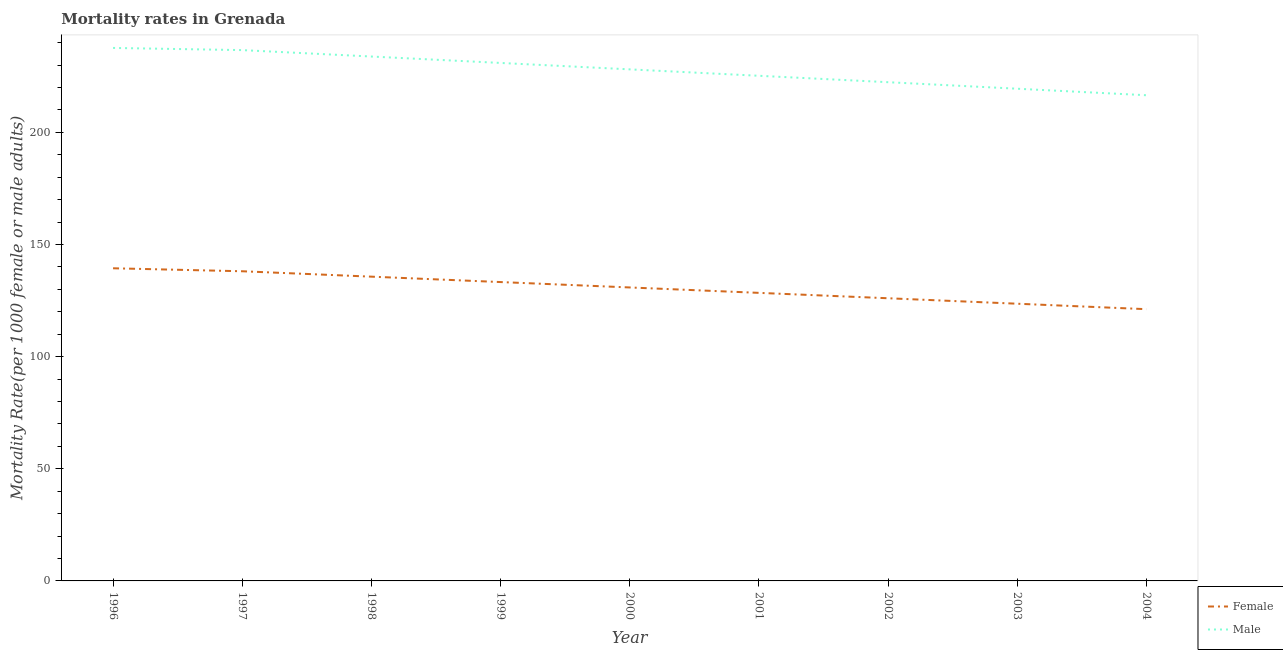Is the number of lines equal to the number of legend labels?
Your response must be concise. Yes. What is the female mortality rate in 2000?
Provide a short and direct response. 130.86. Across all years, what is the maximum female mortality rate?
Give a very brief answer. 139.41. Across all years, what is the minimum female mortality rate?
Your answer should be compact. 121.18. What is the total female mortality rate in the graph?
Your answer should be very brief. 1176.59. What is the difference between the female mortality rate in 2000 and that in 2001?
Offer a terse response. 2.41. What is the difference between the female mortality rate in 1999 and the male mortality rate in 2000?
Provide a short and direct response. -94.84. What is the average female mortality rate per year?
Keep it short and to the point. 130.73. In the year 1998, what is the difference between the female mortality rate and male mortality rate?
Provide a short and direct response. -98.16. In how many years, is the female mortality rate greater than 10?
Keep it short and to the point. 9. What is the ratio of the male mortality rate in 1999 to that in 2002?
Provide a short and direct response. 1.04. What is the difference between the highest and the second highest female mortality rate?
Your response must be concise. 1.33. What is the difference between the highest and the lowest female mortality rate?
Offer a terse response. 18.24. Is the female mortality rate strictly greater than the male mortality rate over the years?
Your response must be concise. No. How many lines are there?
Make the answer very short. 2. How many years are there in the graph?
Your response must be concise. 9. Are the values on the major ticks of Y-axis written in scientific E-notation?
Offer a very short reply. No. Does the graph contain any zero values?
Your answer should be very brief. No. Does the graph contain grids?
Give a very brief answer. No. How many legend labels are there?
Offer a very short reply. 2. What is the title of the graph?
Your response must be concise. Mortality rates in Grenada. Does "Overweight" appear as one of the legend labels in the graph?
Offer a terse response. No. What is the label or title of the Y-axis?
Offer a terse response. Mortality Rate(per 1000 female or male adults). What is the Mortality Rate(per 1000 female or male adults) of Female in 1996?
Your answer should be very brief. 139.41. What is the Mortality Rate(per 1000 female or male adults) in Male in 1996?
Keep it short and to the point. 237.67. What is the Mortality Rate(per 1000 female or male adults) in Female in 1997?
Your answer should be very brief. 138.08. What is the Mortality Rate(per 1000 female or male adults) of Male in 1997?
Provide a short and direct response. 236.7. What is the Mortality Rate(per 1000 female or male adults) of Female in 1998?
Your answer should be very brief. 135.68. What is the Mortality Rate(per 1000 female or male adults) in Male in 1998?
Your answer should be very brief. 233.84. What is the Mortality Rate(per 1000 female or male adults) of Female in 1999?
Your answer should be compact. 133.27. What is the Mortality Rate(per 1000 female or male adults) in Male in 1999?
Give a very brief answer. 230.97. What is the Mortality Rate(per 1000 female or male adults) in Female in 2000?
Keep it short and to the point. 130.86. What is the Mortality Rate(per 1000 female or male adults) in Male in 2000?
Ensure brevity in your answer.  228.11. What is the Mortality Rate(per 1000 female or male adults) in Female in 2001?
Give a very brief answer. 128.45. What is the Mortality Rate(per 1000 female or male adults) of Male in 2001?
Keep it short and to the point. 225.25. What is the Mortality Rate(per 1000 female or male adults) of Female in 2002?
Provide a succinct answer. 126.05. What is the Mortality Rate(per 1000 female or male adults) in Male in 2002?
Ensure brevity in your answer.  222.39. What is the Mortality Rate(per 1000 female or male adults) of Female in 2003?
Provide a short and direct response. 123.61. What is the Mortality Rate(per 1000 female or male adults) in Male in 2003?
Your response must be concise. 219.48. What is the Mortality Rate(per 1000 female or male adults) in Female in 2004?
Your response must be concise. 121.18. What is the Mortality Rate(per 1000 female or male adults) in Male in 2004?
Offer a terse response. 216.58. Across all years, what is the maximum Mortality Rate(per 1000 female or male adults) of Female?
Offer a terse response. 139.41. Across all years, what is the maximum Mortality Rate(per 1000 female or male adults) of Male?
Provide a succinct answer. 237.67. Across all years, what is the minimum Mortality Rate(per 1000 female or male adults) of Female?
Offer a very short reply. 121.18. Across all years, what is the minimum Mortality Rate(per 1000 female or male adults) in Male?
Offer a terse response. 216.58. What is the total Mortality Rate(per 1000 female or male adults) in Female in the graph?
Provide a succinct answer. 1176.59. What is the total Mortality Rate(per 1000 female or male adults) in Male in the graph?
Offer a very short reply. 2050.99. What is the difference between the Mortality Rate(per 1000 female or male adults) of Female in 1996 and that in 1997?
Your answer should be compact. 1.33. What is the difference between the Mortality Rate(per 1000 female or male adults) in Female in 1996 and that in 1998?
Provide a short and direct response. 3.74. What is the difference between the Mortality Rate(per 1000 female or male adults) of Male in 1996 and that in 1998?
Provide a succinct answer. 3.83. What is the difference between the Mortality Rate(per 1000 female or male adults) in Female in 1996 and that in 1999?
Offer a very short reply. 6.14. What is the difference between the Mortality Rate(per 1000 female or male adults) of Male in 1996 and that in 1999?
Offer a terse response. 6.69. What is the difference between the Mortality Rate(per 1000 female or male adults) of Female in 1996 and that in 2000?
Provide a succinct answer. 8.55. What is the difference between the Mortality Rate(per 1000 female or male adults) in Male in 1996 and that in 2000?
Provide a short and direct response. 9.55. What is the difference between the Mortality Rate(per 1000 female or male adults) of Female in 1996 and that in 2001?
Keep it short and to the point. 10.96. What is the difference between the Mortality Rate(per 1000 female or male adults) in Male in 1996 and that in 2001?
Provide a succinct answer. 12.42. What is the difference between the Mortality Rate(per 1000 female or male adults) of Female in 1996 and that in 2002?
Your response must be concise. 13.37. What is the difference between the Mortality Rate(per 1000 female or male adults) in Male in 1996 and that in 2002?
Ensure brevity in your answer.  15.28. What is the difference between the Mortality Rate(per 1000 female or male adults) in Female in 1996 and that in 2003?
Make the answer very short. 15.8. What is the difference between the Mortality Rate(per 1000 female or male adults) of Male in 1996 and that in 2003?
Keep it short and to the point. 18.18. What is the difference between the Mortality Rate(per 1000 female or male adults) in Female in 1996 and that in 2004?
Offer a very short reply. 18.24. What is the difference between the Mortality Rate(per 1000 female or male adults) in Male in 1996 and that in 2004?
Give a very brief answer. 21.09. What is the difference between the Mortality Rate(per 1000 female or male adults) in Female in 1997 and that in 1998?
Keep it short and to the point. 2.41. What is the difference between the Mortality Rate(per 1000 female or male adults) in Male in 1997 and that in 1998?
Make the answer very short. 2.86. What is the difference between the Mortality Rate(per 1000 female or male adults) of Female in 1997 and that in 1999?
Your response must be concise. 4.82. What is the difference between the Mortality Rate(per 1000 female or male adults) in Male in 1997 and that in 1999?
Provide a succinct answer. 5.72. What is the difference between the Mortality Rate(per 1000 female or male adults) in Female in 1997 and that in 2000?
Your answer should be very brief. 7.22. What is the difference between the Mortality Rate(per 1000 female or male adults) in Male in 1997 and that in 2000?
Provide a succinct answer. 8.59. What is the difference between the Mortality Rate(per 1000 female or male adults) in Female in 1997 and that in 2001?
Keep it short and to the point. 9.63. What is the difference between the Mortality Rate(per 1000 female or male adults) in Male in 1997 and that in 2001?
Provide a short and direct response. 11.45. What is the difference between the Mortality Rate(per 1000 female or male adults) in Female in 1997 and that in 2002?
Give a very brief answer. 12.04. What is the difference between the Mortality Rate(per 1000 female or male adults) in Male in 1997 and that in 2002?
Your answer should be compact. 14.31. What is the difference between the Mortality Rate(per 1000 female or male adults) of Female in 1997 and that in 2003?
Make the answer very short. 14.47. What is the difference between the Mortality Rate(per 1000 female or male adults) in Male in 1997 and that in 2003?
Your answer should be very brief. 17.21. What is the difference between the Mortality Rate(per 1000 female or male adults) in Female in 1997 and that in 2004?
Make the answer very short. 16.91. What is the difference between the Mortality Rate(per 1000 female or male adults) of Male in 1997 and that in 2004?
Keep it short and to the point. 20.12. What is the difference between the Mortality Rate(per 1000 female or male adults) of Female in 1998 and that in 1999?
Keep it short and to the point. 2.41. What is the difference between the Mortality Rate(per 1000 female or male adults) in Male in 1998 and that in 1999?
Provide a short and direct response. 2.86. What is the difference between the Mortality Rate(per 1000 female or male adults) of Female in 1998 and that in 2000?
Give a very brief answer. 4.82. What is the difference between the Mortality Rate(per 1000 female or male adults) in Male in 1998 and that in 2000?
Your answer should be compact. 5.72. What is the difference between the Mortality Rate(per 1000 female or male adults) of Female in 1998 and that in 2001?
Your response must be concise. 7.22. What is the difference between the Mortality Rate(per 1000 female or male adults) of Male in 1998 and that in 2001?
Make the answer very short. 8.59. What is the difference between the Mortality Rate(per 1000 female or male adults) of Female in 1998 and that in 2002?
Give a very brief answer. 9.63. What is the difference between the Mortality Rate(per 1000 female or male adults) of Male in 1998 and that in 2002?
Ensure brevity in your answer.  11.45. What is the difference between the Mortality Rate(per 1000 female or male adults) of Female in 1998 and that in 2003?
Your answer should be very brief. 12.06. What is the difference between the Mortality Rate(per 1000 female or male adults) in Male in 1998 and that in 2003?
Your response must be concise. 14.35. What is the difference between the Mortality Rate(per 1000 female or male adults) of Male in 1998 and that in 2004?
Offer a terse response. 17.26. What is the difference between the Mortality Rate(per 1000 female or male adults) in Female in 1999 and that in 2000?
Make the answer very short. 2.41. What is the difference between the Mortality Rate(per 1000 female or male adults) of Male in 1999 and that in 2000?
Offer a very short reply. 2.86. What is the difference between the Mortality Rate(per 1000 female or male adults) of Female in 1999 and that in 2001?
Keep it short and to the point. 4.82. What is the difference between the Mortality Rate(per 1000 female or male adults) in Male in 1999 and that in 2001?
Provide a short and direct response. 5.72. What is the difference between the Mortality Rate(per 1000 female or male adults) of Female in 1999 and that in 2002?
Ensure brevity in your answer.  7.22. What is the difference between the Mortality Rate(per 1000 female or male adults) in Male in 1999 and that in 2002?
Offer a very short reply. 8.59. What is the difference between the Mortality Rate(per 1000 female or male adults) in Female in 1999 and that in 2003?
Your answer should be very brief. 9.66. What is the difference between the Mortality Rate(per 1000 female or male adults) in Male in 1999 and that in 2003?
Your answer should be very brief. 11.49. What is the difference between the Mortality Rate(per 1000 female or male adults) of Female in 1999 and that in 2004?
Your answer should be very brief. 12.09. What is the difference between the Mortality Rate(per 1000 female or male adults) of Male in 1999 and that in 2004?
Offer a very short reply. 14.4. What is the difference between the Mortality Rate(per 1000 female or male adults) in Female in 2000 and that in 2001?
Offer a terse response. 2.41. What is the difference between the Mortality Rate(per 1000 female or male adults) in Male in 2000 and that in 2001?
Give a very brief answer. 2.86. What is the difference between the Mortality Rate(per 1000 female or male adults) of Female in 2000 and that in 2002?
Make the answer very short. 4.82. What is the difference between the Mortality Rate(per 1000 female or male adults) in Male in 2000 and that in 2002?
Ensure brevity in your answer.  5.72. What is the difference between the Mortality Rate(per 1000 female or male adults) in Female in 2000 and that in 2003?
Your response must be concise. 7.25. What is the difference between the Mortality Rate(per 1000 female or male adults) of Male in 2000 and that in 2003?
Make the answer very short. 8.63. What is the difference between the Mortality Rate(per 1000 female or male adults) of Female in 2000 and that in 2004?
Your answer should be compact. 9.69. What is the difference between the Mortality Rate(per 1000 female or male adults) of Male in 2000 and that in 2004?
Make the answer very short. 11.53. What is the difference between the Mortality Rate(per 1000 female or male adults) in Female in 2001 and that in 2002?
Your answer should be very brief. 2.41. What is the difference between the Mortality Rate(per 1000 female or male adults) of Male in 2001 and that in 2002?
Provide a short and direct response. 2.86. What is the difference between the Mortality Rate(per 1000 female or male adults) in Female in 2001 and that in 2003?
Your response must be concise. 4.84. What is the difference between the Mortality Rate(per 1000 female or male adults) in Male in 2001 and that in 2003?
Provide a short and direct response. 5.77. What is the difference between the Mortality Rate(per 1000 female or male adults) of Female in 2001 and that in 2004?
Your response must be concise. 7.28. What is the difference between the Mortality Rate(per 1000 female or male adults) in Male in 2001 and that in 2004?
Offer a very short reply. 8.67. What is the difference between the Mortality Rate(per 1000 female or male adults) of Female in 2002 and that in 2003?
Your response must be concise. 2.43. What is the difference between the Mortality Rate(per 1000 female or male adults) in Male in 2002 and that in 2003?
Keep it short and to the point. 2.9. What is the difference between the Mortality Rate(per 1000 female or male adults) in Female in 2002 and that in 2004?
Keep it short and to the point. 4.87. What is the difference between the Mortality Rate(per 1000 female or male adults) of Male in 2002 and that in 2004?
Provide a succinct answer. 5.81. What is the difference between the Mortality Rate(per 1000 female or male adults) of Female in 2003 and that in 2004?
Ensure brevity in your answer.  2.44. What is the difference between the Mortality Rate(per 1000 female or male adults) of Male in 2003 and that in 2004?
Make the answer very short. 2.9. What is the difference between the Mortality Rate(per 1000 female or male adults) in Female in 1996 and the Mortality Rate(per 1000 female or male adults) in Male in 1997?
Provide a succinct answer. -97.29. What is the difference between the Mortality Rate(per 1000 female or male adults) of Female in 1996 and the Mortality Rate(per 1000 female or male adults) of Male in 1998?
Your response must be concise. -94.42. What is the difference between the Mortality Rate(per 1000 female or male adults) in Female in 1996 and the Mortality Rate(per 1000 female or male adults) in Male in 1999?
Keep it short and to the point. -91.56. What is the difference between the Mortality Rate(per 1000 female or male adults) of Female in 1996 and the Mortality Rate(per 1000 female or male adults) of Male in 2000?
Make the answer very short. -88.7. What is the difference between the Mortality Rate(per 1000 female or male adults) in Female in 1996 and the Mortality Rate(per 1000 female or male adults) in Male in 2001?
Offer a very short reply. -85.84. What is the difference between the Mortality Rate(per 1000 female or male adults) in Female in 1996 and the Mortality Rate(per 1000 female or male adults) in Male in 2002?
Your answer should be compact. -82.98. What is the difference between the Mortality Rate(per 1000 female or male adults) in Female in 1996 and the Mortality Rate(per 1000 female or male adults) in Male in 2003?
Your answer should be compact. -80.07. What is the difference between the Mortality Rate(per 1000 female or male adults) of Female in 1996 and the Mortality Rate(per 1000 female or male adults) of Male in 2004?
Provide a short and direct response. -77.17. What is the difference between the Mortality Rate(per 1000 female or male adults) of Female in 1997 and the Mortality Rate(per 1000 female or male adults) of Male in 1998?
Keep it short and to the point. -95.75. What is the difference between the Mortality Rate(per 1000 female or male adults) in Female in 1997 and the Mortality Rate(per 1000 female or male adults) in Male in 1999?
Provide a short and direct response. -92.89. What is the difference between the Mortality Rate(per 1000 female or male adults) in Female in 1997 and the Mortality Rate(per 1000 female or male adults) in Male in 2000?
Give a very brief answer. -90.03. What is the difference between the Mortality Rate(per 1000 female or male adults) of Female in 1997 and the Mortality Rate(per 1000 female or male adults) of Male in 2001?
Your answer should be compact. -87.17. What is the difference between the Mortality Rate(per 1000 female or male adults) in Female in 1997 and the Mortality Rate(per 1000 female or male adults) in Male in 2002?
Ensure brevity in your answer.  -84.3. What is the difference between the Mortality Rate(per 1000 female or male adults) of Female in 1997 and the Mortality Rate(per 1000 female or male adults) of Male in 2003?
Ensure brevity in your answer.  -81.4. What is the difference between the Mortality Rate(per 1000 female or male adults) of Female in 1997 and the Mortality Rate(per 1000 female or male adults) of Male in 2004?
Offer a terse response. -78.49. What is the difference between the Mortality Rate(per 1000 female or male adults) in Female in 1998 and the Mortality Rate(per 1000 female or male adults) in Male in 1999?
Offer a terse response. -95.3. What is the difference between the Mortality Rate(per 1000 female or male adults) in Female in 1998 and the Mortality Rate(per 1000 female or male adults) in Male in 2000?
Your response must be concise. -92.44. What is the difference between the Mortality Rate(per 1000 female or male adults) of Female in 1998 and the Mortality Rate(per 1000 female or male adults) of Male in 2001?
Ensure brevity in your answer.  -89.57. What is the difference between the Mortality Rate(per 1000 female or male adults) in Female in 1998 and the Mortality Rate(per 1000 female or male adults) in Male in 2002?
Provide a short and direct response. -86.71. What is the difference between the Mortality Rate(per 1000 female or male adults) in Female in 1998 and the Mortality Rate(per 1000 female or male adults) in Male in 2003?
Provide a succinct answer. -83.81. What is the difference between the Mortality Rate(per 1000 female or male adults) of Female in 1998 and the Mortality Rate(per 1000 female or male adults) of Male in 2004?
Your answer should be very brief. -80.9. What is the difference between the Mortality Rate(per 1000 female or male adults) of Female in 1999 and the Mortality Rate(per 1000 female or male adults) of Male in 2000?
Ensure brevity in your answer.  -94.84. What is the difference between the Mortality Rate(per 1000 female or male adults) of Female in 1999 and the Mortality Rate(per 1000 female or male adults) of Male in 2001?
Offer a terse response. -91.98. What is the difference between the Mortality Rate(per 1000 female or male adults) in Female in 1999 and the Mortality Rate(per 1000 female or male adults) in Male in 2002?
Provide a succinct answer. -89.12. What is the difference between the Mortality Rate(per 1000 female or male adults) of Female in 1999 and the Mortality Rate(per 1000 female or male adults) of Male in 2003?
Offer a very short reply. -86.21. What is the difference between the Mortality Rate(per 1000 female or male adults) of Female in 1999 and the Mortality Rate(per 1000 female or male adults) of Male in 2004?
Make the answer very short. -83.31. What is the difference between the Mortality Rate(per 1000 female or male adults) of Female in 2000 and the Mortality Rate(per 1000 female or male adults) of Male in 2001?
Provide a succinct answer. -94.39. What is the difference between the Mortality Rate(per 1000 female or male adults) of Female in 2000 and the Mortality Rate(per 1000 female or male adults) of Male in 2002?
Provide a succinct answer. -91.53. What is the difference between the Mortality Rate(per 1000 female or male adults) in Female in 2000 and the Mortality Rate(per 1000 female or male adults) in Male in 2003?
Offer a very short reply. -88.62. What is the difference between the Mortality Rate(per 1000 female or male adults) of Female in 2000 and the Mortality Rate(per 1000 female or male adults) of Male in 2004?
Provide a short and direct response. -85.72. What is the difference between the Mortality Rate(per 1000 female or male adults) in Female in 2001 and the Mortality Rate(per 1000 female or male adults) in Male in 2002?
Your answer should be very brief. -93.94. What is the difference between the Mortality Rate(per 1000 female or male adults) in Female in 2001 and the Mortality Rate(per 1000 female or male adults) in Male in 2003?
Give a very brief answer. -91.03. What is the difference between the Mortality Rate(per 1000 female or male adults) of Female in 2001 and the Mortality Rate(per 1000 female or male adults) of Male in 2004?
Give a very brief answer. -88.12. What is the difference between the Mortality Rate(per 1000 female or male adults) in Female in 2002 and the Mortality Rate(per 1000 female or male adults) in Male in 2003?
Offer a very short reply. -93.44. What is the difference between the Mortality Rate(per 1000 female or male adults) of Female in 2002 and the Mortality Rate(per 1000 female or male adults) of Male in 2004?
Keep it short and to the point. -90.53. What is the difference between the Mortality Rate(per 1000 female or male adults) in Female in 2003 and the Mortality Rate(per 1000 female or male adults) in Male in 2004?
Your response must be concise. -92.97. What is the average Mortality Rate(per 1000 female or male adults) in Female per year?
Offer a terse response. 130.73. What is the average Mortality Rate(per 1000 female or male adults) in Male per year?
Give a very brief answer. 227.89. In the year 1996, what is the difference between the Mortality Rate(per 1000 female or male adults) in Female and Mortality Rate(per 1000 female or male adults) in Male?
Ensure brevity in your answer.  -98.25. In the year 1997, what is the difference between the Mortality Rate(per 1000 female or male adults) in Female and Mortality Rate(per 1000 female or male adults) in Male?
Provide a succinct answer. -98.61. In the year 1998, what is the difference between the Mortality Rate(per 1000 female or male adults) of Female and Mortality Rate(per 1000 female or male adults) of Male?
Offer a very short reply. -98.16. In the year 1999, what is the difference between the Mortality Rate(per 1000 female or male adults) in Female and Mortality Rate(per 1000 female or male adults) in Male?
Offer a very short reply. -97.7. In the year 2000, what is the difference between the Mortality Rate(per 1000 female or male adults) in Female and Mortality Rate(per 1000 female or male adults) in Male?
Offer a terse response. -97.25. In the year 2001, what is the difference between the Mortality Rate(per 1000 female or male adults) of Female and Mortality Rate(per 1000 female or male adults) of Male?
Provide a short and direct response. -96.8. In the year 2002, what is the difference between the Mortality Rate(per 1000 female or male adults) in Female and Mortality Rate(per 1000 female or male adults) in Male?
Offer a terse response. -96.34. In the year 2003, what is the difference between the Mortality Rate(per 1000 female or male adults) in Female and Mortality Rate(per 1000 female or male adults) in Male?
Provide a succinct answer. -95.87. In the year 2004, what is the difference between the Mortality Rate(per 1000 female or male adults) of Female and Mortality Rate(per 1000 female or male adults) of Male?
Ensure brevity in your answer.  -95.4. What is the ratio of the Mortality Rate(per 1000 female or male adults) of Female in 1996 to that in 1997?
Keep it short and to the point. 1.01. What is the ratio of the Mortality Rate(per 1000 female or male adults) of Male in 1996 to that in 1997?
Offer a terse response. 1. What is the ratio of the Mortality Rate(per 1000 female or male adults) of Female in 1996 to that in 1998?
Keep it short and to the point. 1.03. What is the ratio of the Mortality Rate(per 1000 female or male adults) of Male in 1996 to that in 1998?
Give a very brief answer. 1.02. What is the ratio of the Mortality Rate(per 1000 female or male adults) in Female in 1996 to that in 1999?
Your answer should be very brief. 1.05. What is the ratio of the Mortality Rate(per 1000 female or male adults) in Male in 1996 to that in 1999?
Your response must be concise. 1.03. What is the ratio of the Mortality Rate(per 1000 female or male adults) in Female in 1996 to that in 2000?
Offer a very short reply. 1.07. What is the ratio of the Mortality Rate(per 1000 female or male adults) in Male in 1996 to that in 2000?
Ensure brevity in your answer.  1.04. What is the ratio of the Mortality Rate(per 1000 female or male adults) in Female in 1996 to that in 2001?
Your answer should be very brief. 1.09. What is the ratio of the Mortality Rate(per 1000 female or male adults) in Male in 1996 to that in 2001?
Give a very brief answer. 1.06. What is the ratio of the Mortality Rate(per 1000 female or male adults) of Female in 1996 to that in 2002?
Give a very brief answer. 1.11. What is the ratio of the Mortality Rate(per 1000 female or male adults) of Male in 1996 to that in 2002?
Your answer should be compact. 1.07. What is the ratio of the Mortality Rate(per 1000 female or male adults) of Female in 1996 to that in 2003?
Offer a very short reply. 1.13. What is the ratio of the Mortality Rate(per 1000 female or male adults) in Male in 1996 to that in 2003?
Your answer should be very brief. 1.08. What is the ratio of the Mortality Rate(per 1000 female or male adults) in Female in 1996 to that in 2004?
Your response must be concise. 1.15. What is the ratio of the Mortality Rate(per 1000 female or male adults) in Male in 1996 to that in 2004?
Give a very brief answer. 1.1. What is the ratio of the Mortality Rate(per 1000 female or male adults) of Female in 1997 to that in 1998?
Ensure brevity in your answer.  1.02. What is the ratio of the Mortality Rate(per 1000 female or male adults) of Male in 1997 to that in 1998?
Give a very brief answer. 1.01. What is the ratio of the Mortality Rate(per 1000 female or male adults) in Female in 1997 to that in 1999?
Ensure brevity in your answer.  1.04. What is the ratio of the Mortality Rate(per 1000 female or male adults) in Male in 1997 to that in 1999?
Provide a short and direct response. 1.02. What is the ratio of the Mortality Rate(per 1000 female or male adults) of Female in 1997 to that in 2000?
Offer a terse response. 1.06. What is the ratio of the Mortality Rate(per 1000 female or male adults) in Male in 1997 to that in 2000?
Your answer should be very brief. 1.04. What is the ratio of the Mortality Rate(per 1000 female or male adults) in Female in 1997 to that in 2001?
Your answer should be compact. 1.07. What is the ratio of the Mortality Rate(per 1000 female or male adults) in Male in 1997 to that in 2001?
Ensure brevity in your answer.  1.05. What is the ratio of the Mortality Rate(per 1000 female or male adults) of Female in 1997 to that in 2002?
Offer a terse response. 1.1. What is the ratio of the Mortality Rate(per 1000 female or male adults) of Male in 1997 to that in 2002?
Your answer should be compact. 1.06. What is the ratio of the Mortality Rate(per 1000 female or male adults) in Female in 1997 to that in 2003?
Keep it short and to the point. 1.12. What is the ratio of the Mortality Rate(per 1000 female or male adults) in Male in 1997 to that in 2003?
Your answer should be compact. 1.08. What is the ratio of the Mortality Rate(per 1000 female or male adults) in Female in 1997 to that in 2004?
Offer a very short reply. 1.14. What is the ratio of the Mortality Rate(per 1000 female or male adults) of Male in 1997 to that in 2004?
Provide a short and direct response. 1.09. What is the ratio of the Mortality Rate(per 1000 female or male adults) of Female in 1998 to that in 1999?
Ensure brevity in your answer.  1.02. What is the ratio of the Mortality Rate(per 1000 female or male adults) of Male in 1998 to that in 1999?
Keep it short and to the point. 1.01. What is the ratio of the Mortality Rate(per 1000 female or male adults) of Female in 1998 to that in 2000?
Your answer should be very brief. 1.04. What is the ratio of the Mortality Rate(per 1000 female or male adults) of Male in 1998 to that in 2000?
Ensure brevity in your answer.  1.03. What is the ratio of the Mortality Rate(per 1000 female or male adults) of Female in 1998 to that in 2001?
Your answer should be very brief. 1.06. What is the ratio of the Mortality Rate(per 1000 female or male adults) in Male in 1998 to that in 2001?
Ensure brevity in your answer.  1.04. What is the ratio of the Mortality Rate(per 1000 female or male adults) in Female in 1998 to that in 2002?
Offer a terse response. 1.08. What is the ratio of the Mortality Rate(per 1000 female or male adults) of Male in 1998 to that in 2002?
Your answer should be very brief. 1.05. What is the ratio of the Mortality Rate(per 1000 female or male adults) in Female in 1998 to that in 2003?
Your answer should be very brief. 1.1. What is the ratio of the Mortality Rate(per 1000 female or male adults) in Male in 1998 to that in 2003?
Your answer should be compact. 1.07. What is the ratio of the Mortality Rate(per 1000 female or male adults) in Female in 1998 to that in 2004?
Ensure brevity in your answer.  1.12. What is the ratio of the Mortality Rate(per 1000 female or male adults) in Male in 1998 to that in 2004?
Provide a short and direct response. 1.08. What is the ratio of the Mortality Rate(per 1000 female or male adults) of Female in 1999 to that in 2000?
Keep it short and to the point. 1.02. What is the ratio of the Mortality Rate(per 1000 female or male adults) in Male in 1999 to that in 2000?
Offer a very short reply. 1.01. What is the ratio of the Mortality Rate(per 1000 female or male adults) of Female in 1999 to that in 2001?
Keep it short and to the point. 1.04. What is the ratio of the Mortality Rate(per 1000 female or male adults) in Male in 1999 to that in 2001?
Provide a succinct answer. 1.03. What is the ratio of the Mortality Rate(per 1000 female or male adults) in Female in 1999 to that in 2002?
Your response must be concise. 1.06. What is the ratio of the Mortality Rate(per 1000 female or male adults) of Male in 1999 to that in 2002?
Offer a very short reply. 1.04. What is the ratio of the Mortality Rate(per 1000 female or male adults) of Female in 1999 to that in 2003?
Give a very brief answer. 1.08. What is the ratio of the Mortality Rate(per 1000 female or male adults) of Male in 1999 to that in 2003?
Your response must be concise. 1.05. What is the ratio of the Mortality Rate(per 1000 female or male adults) in Female in 1999 to that in 2004?
Your response must be concise. 1.1. What is the ratio of the Mortality Rate(per 1000 female or male adults) in Male in 1999 to that in 2004?
Keep it short and to the point. 1.07. What is the ratio of the Mortality Rate(per 1000 female or male adults) in Female in 2000 to that in 2001?
Keep it short and to the point. 1.02. What is the ratio of the Mortality Rate(per 1000 female or male adults) in Male in 2000 to that in 2001?
Offer a terse response. 1.01. What is the ratio of the Mortality Rate(per 1000 female or male adults) in Female in 2000 to that in 2002?
Make the answer very short. 1.04. What is the ratio of the Mortality Rate(per 1000 female or male adults) of Male in 2000 to that in 2002?
Offer a very short reply. 1.03. What is the ratio of the Mortality Rate(per 1000 female or male adults) of Female in 2000 to that in 2003?
Your answer should be compact. 1.06. What is the ratio of the Mortality Rate(per 1000 female or male adults) of Male in 2000 to that in 2003?
Your answer should be compact. 1.04. What is the ratio of the Mortality Rate(per 1000 female or male adults) of Female in 2000 to that in 2004?
Offer a terse response. 1.08. What is the ratio of the Mortality Rate(per 1000 female or male adults) in Male in 2000 to that in 2004?
Your response must be concise. 1.05. What is the ratio of the Mortality Rate(per 1000 female or male adults) of Female in 2001 to that in 2002?
Your answer should be very brief. 1.02. What is the ratio of the Mortality Rate(per 1000 female or male adults) in Male in 2001 to that in 2002?
Provide a short and direct response. 1.01. What is the ratio of the Mortality Rate(per 1000 female or male adults) in Female in 2001 to that in 2003?
Provide a succinct answer. 1.04. What is the ratio of the Mortality Rate(per 1000 female or male adults) of Male in 2001 to that in 2003?
Make the answer very short. 1.03. What is the ratio of the Mortality Rate(per 1000 female or male adults) in Female in 2001 to that in 2004?
Provide a succinct answer. 1.06. What is the ratio of the Mortality Rate(per 1000 female or male adults) in Female in 2002 to that in 2003?
Make the answer very short. 1.02. What is the ratio of the Mortality Rate(per 1000 female or male adults) of Male in 2002 to that in 2003?
Make the answer very short. 1.01. What is the ratio of the Mortality Rate(per 1000 female or male adults) in Female in 2002 to that in 2004?
Keep it short and to the point. 1.04. What is the ratio of the Mortality Rate(per 1000 female or male adults) in Male in 2002 to that in 2004?
Keep it short and to the point. 1.03. What is the ratio of the Mortality Rate(per 1000 female or male adults) in Female in 2003 to that in 2004?
Provide a short and direct response. 1.02. What is the ratio of the Mortality Rate(per 1000 female or male adults) of Male in 2003 to that in 2004?
Offer a very short reply. 1.01. What is the difference between the highest and the second highest Mortality Rate(per 1000 female or male adults) in Female?
Provide a short and direct response. 1.33. What is the difference between the highest and the second highest Mortality Rate(per 1000 female or male adults) in Male?
Give a very brief answer. 0.97. What is the difference between the highest and the lowest Mortality Rate(per 1000 female or male adults) of Female?
Keep it short and to the point. 18.24. What is the difference between the highest and the lowest Mortality Rate(per 1000 female or male adults) in Male?
Offer a terse response. 21.09. 